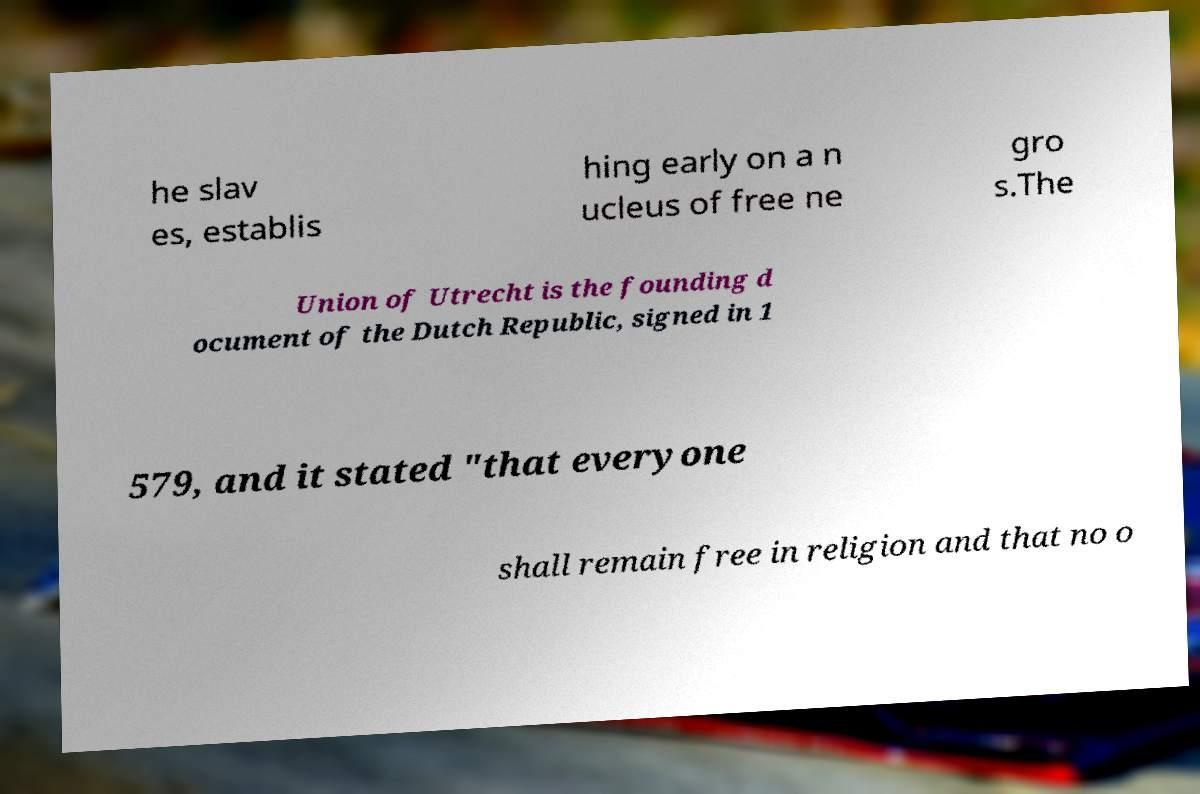Please read and relay the text visible in this image. What does it say? he slav es, establis hing early on a n ucleus of free ne gro s.The Union of Utrecht is the founding d ocument of the Dutch Republic, signed in 1 579, and it stated "that everyone shall remain free in religion and that no o 